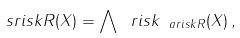<formula> <loc_0><loc_0><loc_500><loc_500>\ s r i s k R ( X ) = \bigwedge \ r i s k _ { \ a r i s k R } ( X ) \, ,</formula> 